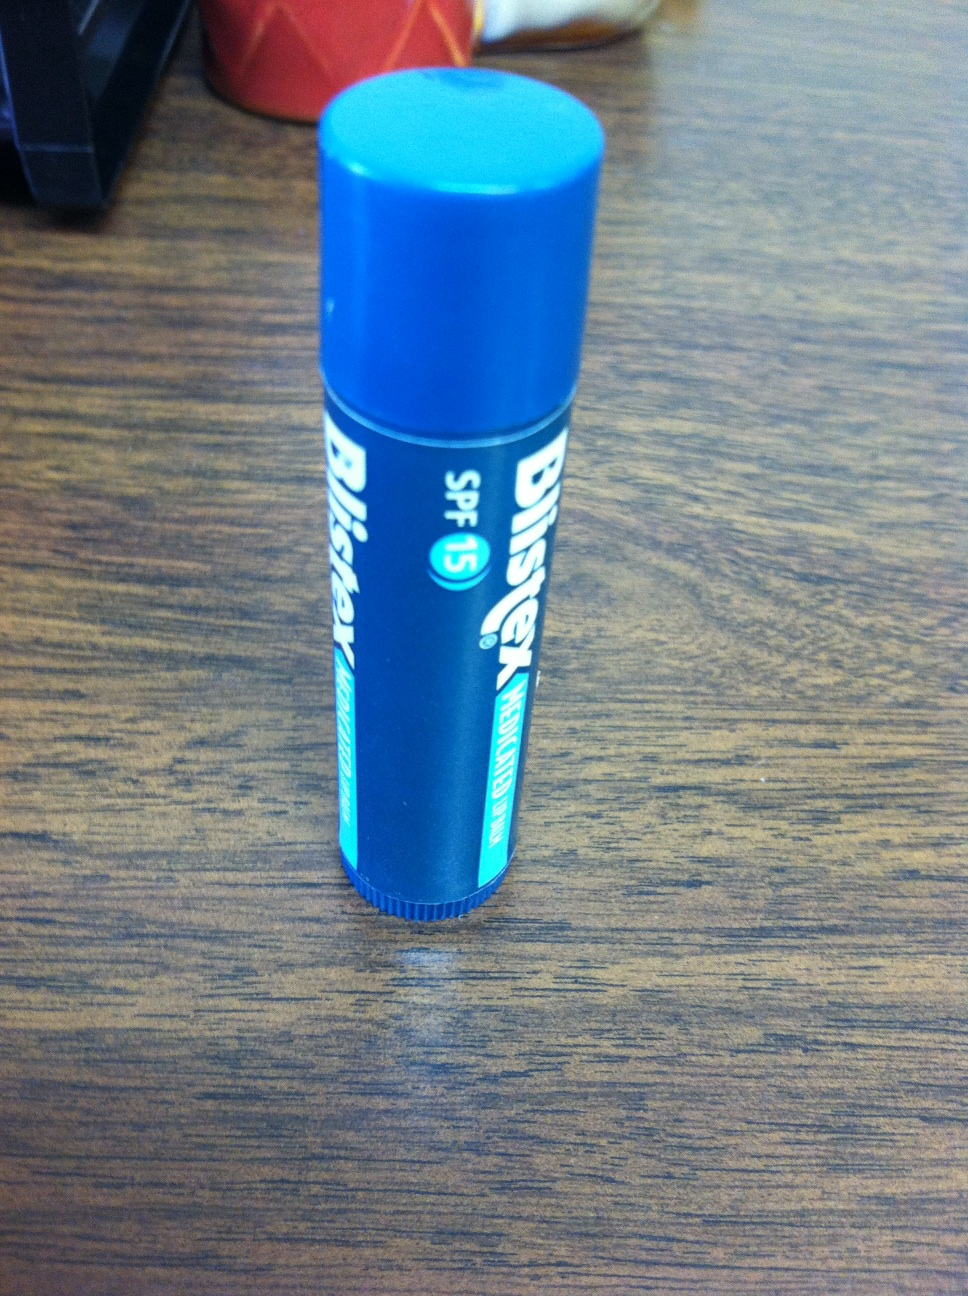Imagine this chapstick was a character in an animated movie. What kind of adventures would it go on? Imagine Blistex, the brave chapstick, embarking on epic adventures to save the world from the Evil Crack, who seeks to dry out and damage all lips across the land! Blistex, with its SPF 15 shield and healing powers, teams up with Lotion Lady and Balm Boy to protect the Lip Kingdom. Along the way, it overcomes fiery deserts, frosty mountains, and windy plains, using its magical hydrating abilities to restore moisture and protect against sunburn, ensuring every inhabitant has healthy, happy lips. In a climactic battle, Blistex must outwit the Evil Crack and seal the pact of eternal comfort, where every smile stays bright and every lip stays smooth forever! 